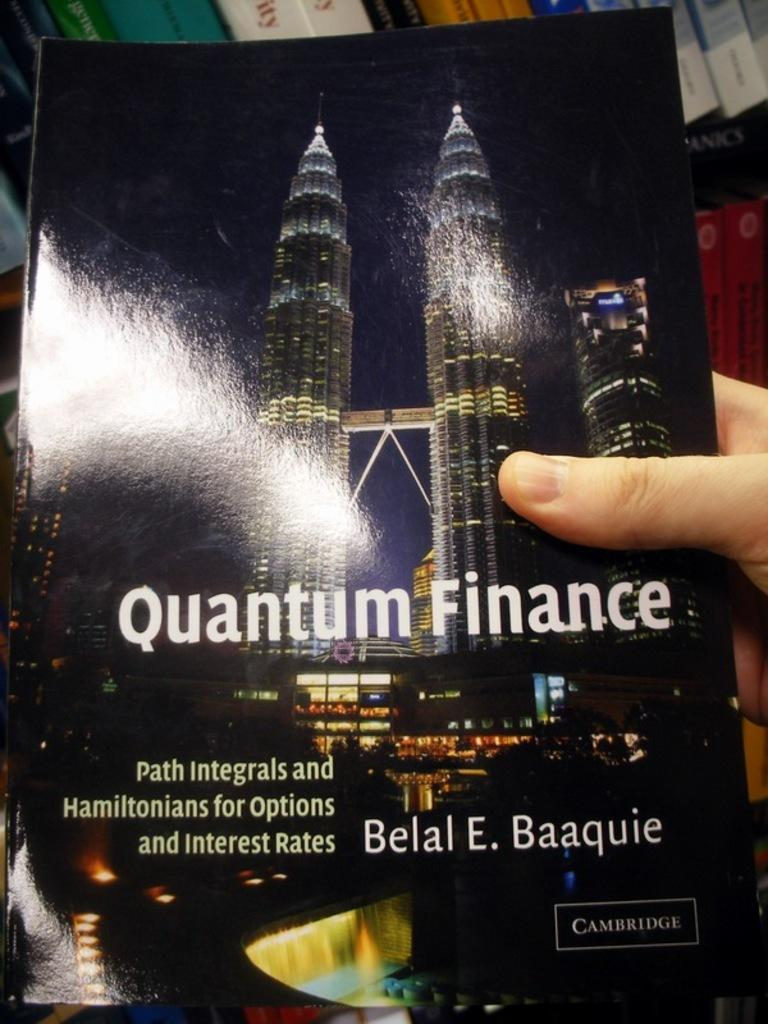<image>
Describe the image concisely. Someone is holding a book called Quantum Finance. 